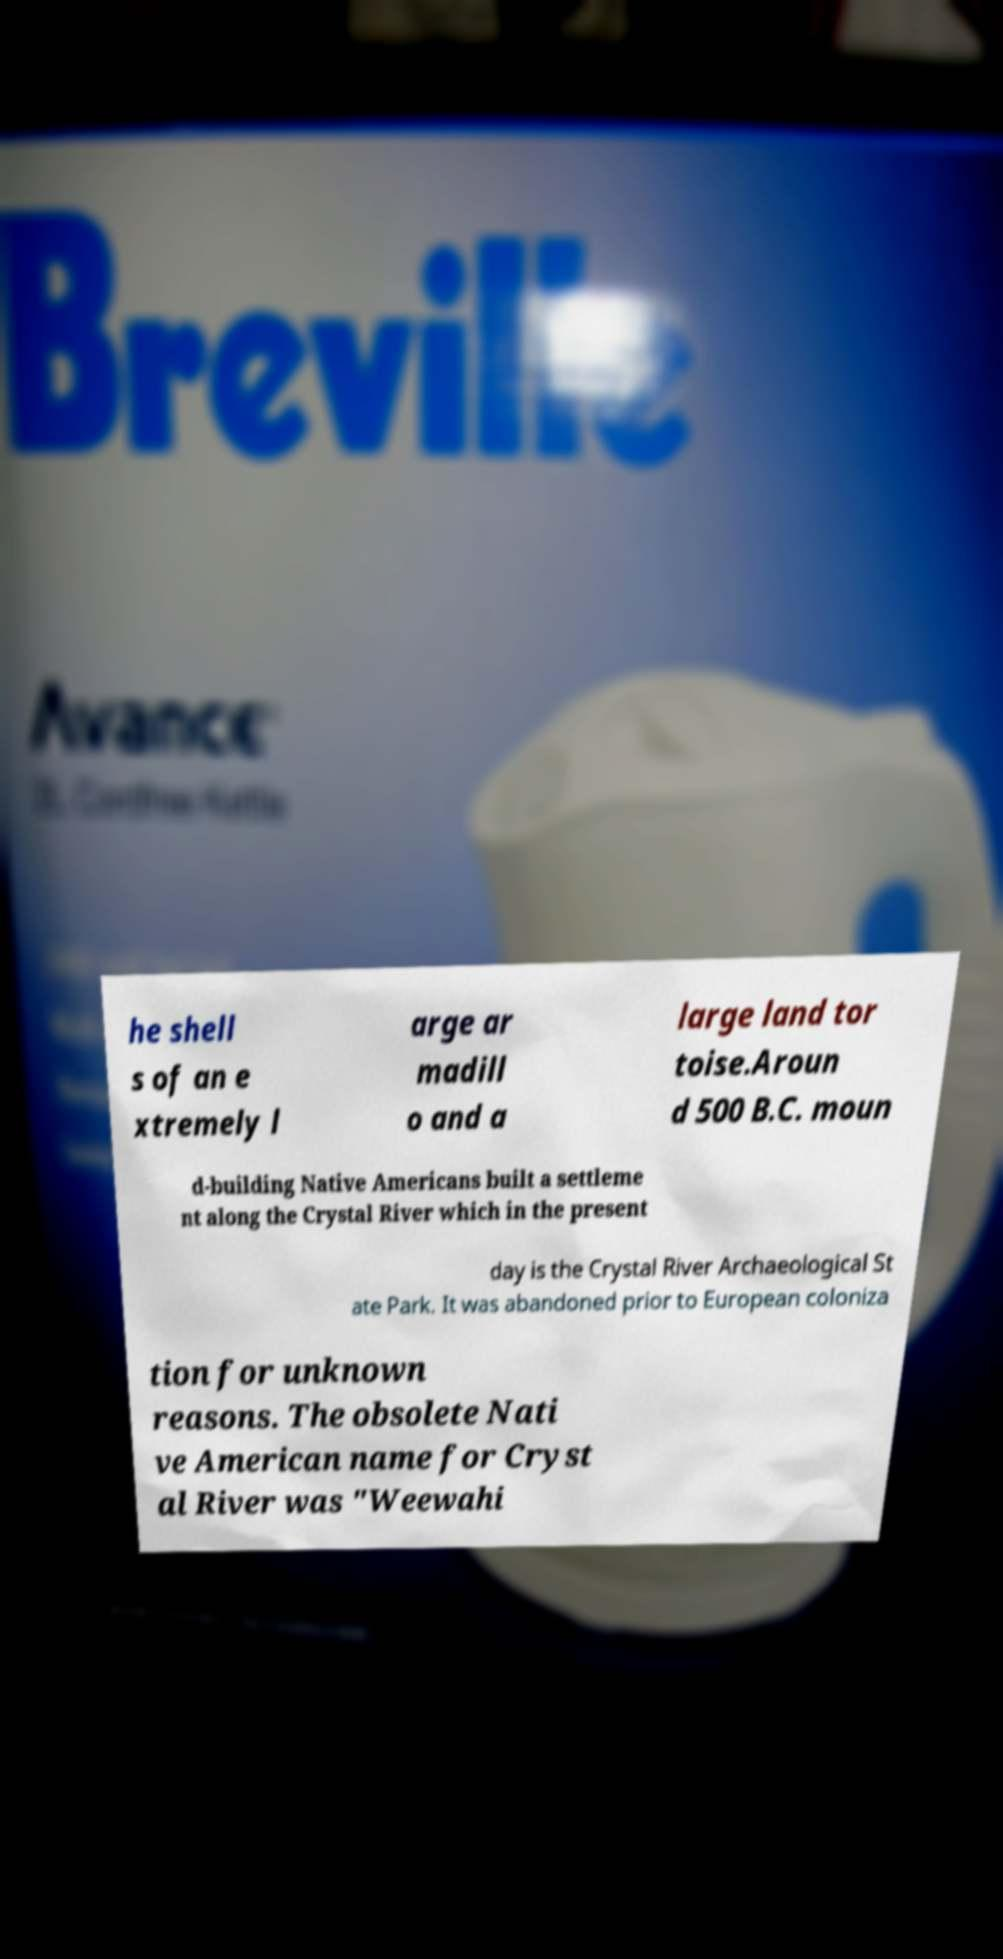What messages or text are displayed in this image? I need them in a readable, typed format. he shell s of an e xtremely l arge ar madill o and a large land tor toise.Aroun d 500 B.C. moun d-building Native Americans built a settleme nt along the Crystal River which in the present day is the Crystal River Archaeological St ate Park. It was abandoned prior to European coloniza tion for unknown reasons. The obsolete Nati ve American name for Cryst al River was "Weewahi 